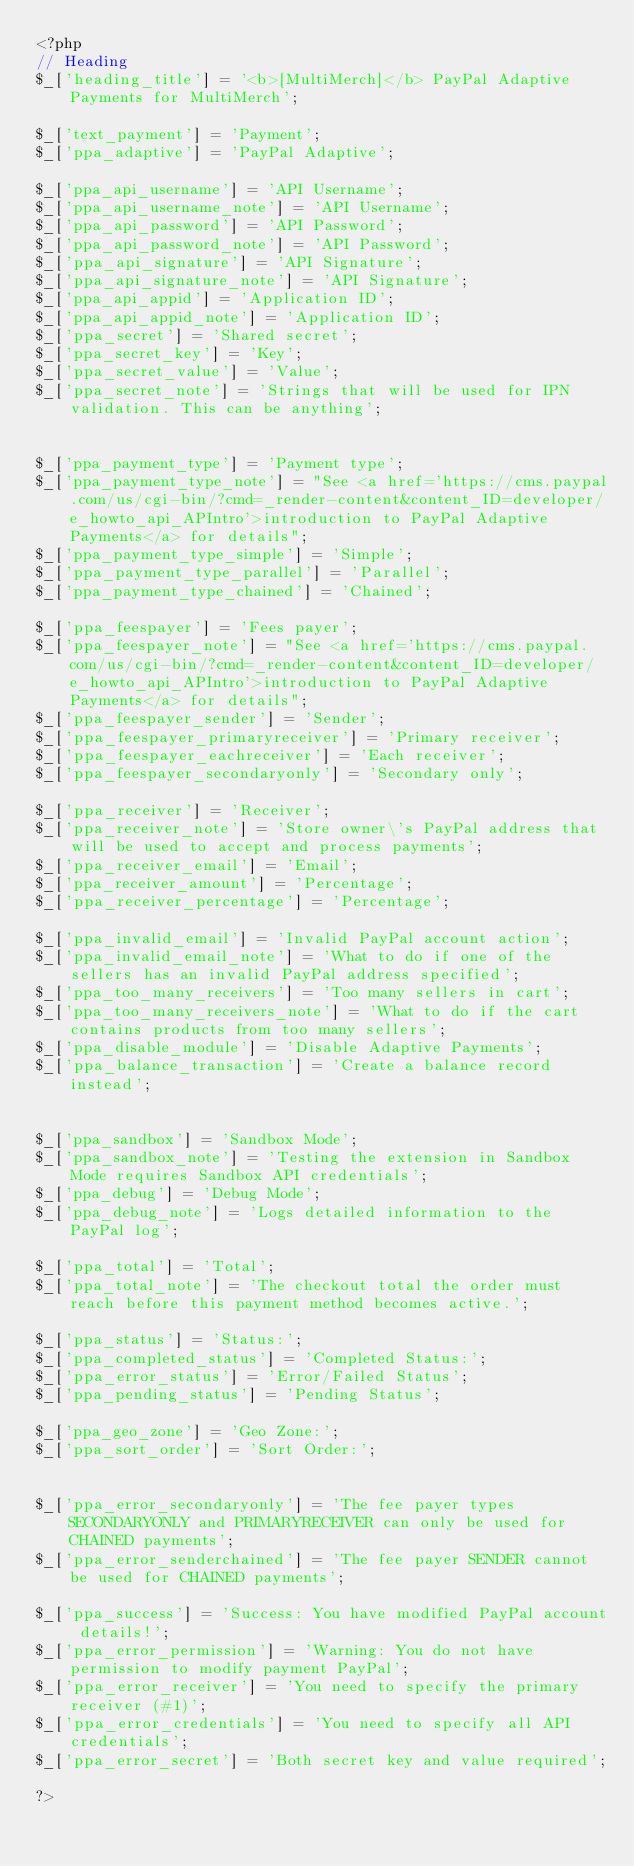<code> <loc_0><loc_0><loc_500><loc_500><_PHP_><?php
// Heading
$_['heading_title'] = '<b>[MultiMerch]</b> PayPal Adaptive Payments for MultiMerch';

$_['text_payment'] = 'Payment';
$_['ppa_adaptive'] = 'PayPal Adaptive';

$_['ppa_api_username'] = 'API Username';
$_['ppa_api_username_note'] = 'API Username';
$_['ppa_api_password'] = 'API Password';
$_['ppa_api_password_note'] = 'API Password';
$_['ppa_api_signature'] = 'API Signature';
$_['ppa_api_signature_note'] = 'API Signature';
$_['ppa_api_appid'] = 'Application ID';
$_['ppa_api_appid_note'] = 'Application ID';
$_['ppa_secret'] = 'Shared secret';
$_['ppa_secret_key'] = 'Key';
$_['ppa_secret_value'] = 'Value';
$_['ppa_secret_note'] = 'Strings that will be used for IPN validation. This can be anything';


$_['ppa_payment_type'] = 'Payment type';
$_['ppa_payment_type_note'] = "See <a href='https://cms.paypal.com/us/cgi-bin/?cmd=_render-content&content_ID=developer/e_howto_api_APIntro'>introduction to PayPal Adaptive Payments</a> for details";
$_['ppa_payment_type_simple'] = 'Simple';
$_['ppa_payment_type_parallel'] = 'Parallel';
$_['ppa_payment_type_chained'] = 'Chained';

$_['ppa_feespayer'] = 'Fees payer';
$_['ppa_feespayer_note'] = "See <a href='https://cms.paypal.com/us/cgi-bin/?cmd=_render-content&content_ID=developer/e_howto_api_APIntro'>introduction to PayPal Adaptive Payments</a> for details";
$_['ppa_feespayer_sender'] = 'Sender';
$_['ppa_feespayer_primaryreceiver'] = 'Primary receiver';
$_['ppa_feespayer_eachreceiver'] = 'Each receiver';
$_['ppa_feespayer_secondaryonly'] = 'Secondary only';

$_['ppa_receiver'] = 'Receiver';
$_['ppa_receiver_note'] = 'Store owner\'s PayPal address that will be used to accept and process payments';
$_['ppa_receiver_email'] = 'Email';
$_['ppa_receiver_amount'] = 'Percentage';
$_['ppa_receiver_percentage'] = 'Percentage';

$_['ppa_invalid_email'] = 'Invalid PayPal account action';
$_['ppa_invalid_email_note'] = 'What to do if one of the sellers has an invalid PayPal address specified';
$_['ppa_too_many_receivers'] = 'Too many sellers in cart';
$_['ppa_too_many_receivers_note'] = 'What to do if the cart contains products from too many sellers';
$_['ppa_disable_module'] = 'Disable Adaptive Payments';
$_['ppa_balance_transaction'] = 'Create a balance record instead';


$_['ppa_sandbox'] = 'Sandbox Mode';
$_['ppa_sandbox_note'] = 'Testing the extension in Sandbox Mode requires Sandbox API credentials';
$_['ppa_debug'] = 'Debug Mode';
$_['ppa_debug_note'] = 'Logs detailed information to the PayPal log';

$_['ppa_total'] = 'Total';
$_['ppa_total_note'] = 'The checkout total the order must reach before this payment method becomes active.';

$_['ppa_status'] = 'Status:';
$_['ppa_completed_status'] = 'Completed Status:';
$_['ppa_error_status'] = 'Error/Failed Status';
$_['ppa_pending_status'] = 'Pending Status';

$_['ppa_geo_zone'] = 'Geo Zone:';
$_['ppa_sort_order'] = 'Sort Order:';


$_['ppa_error_secondaryonly'] = 'The fee payer types SECONDARYONLY and PRIMARYRECEIVER can only be used for CHAINED payments';
$_['ppa_error_senderchained'] = 'The fee payer SENDER cannot be used for CHAINED payments';

$_['ppa_success'] = 'Success: You have modified PayPal account details!';
$_['ppa_error_permission'] = 'Warning: You do not have permission to modify payment PayPal';
$_['ppa_error_receiver'] = 'You need to specify the primary receiver (#1)';
$_['ppa_error_credentials'] = 'You need to specify all API credentials';
$_['ppa_error_secret'] = 'Both secret key and value required';

?></code> 